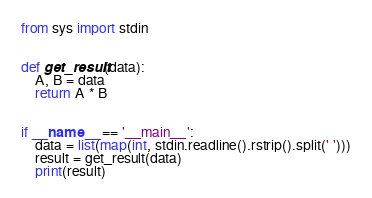Convert code to text. <code><loc_0><loc_0><loc_500><loc_500><_Python_>from sys import stdin


def get_result(data):
    A, B = data
    return A * B


if __name__ == '__main__':
    data = list(map(int, stdin.readline().rstrip().split(' ')))
    result = get_result(data)
    print(result)
</code> 